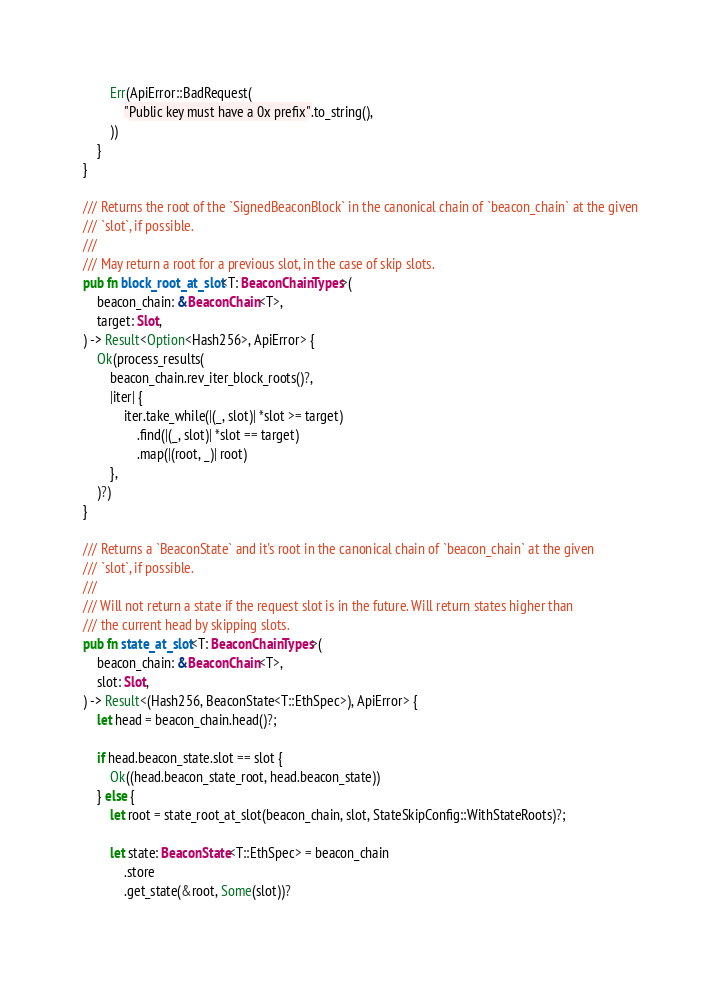<code> <loc_0><loc_0><loc_500><loc_500><_Rust_>        Err(ApiError::BadRequest(
            "Public key must have a 0x prefix".to_string(),
        ))
    }
}

/// Returns the root of the `SignedBeaconBlock` in the canonical chain of `beacon_chain` at the given
/// `slot`, if possible.
///
/// May return a root for a previous slot, in the case of skip slots.
pub fn block_root_at_slot<T: BeaconChainTypes>(
    beacon_chain: &BeaconChain<T>,
    target: Slot,
) -> Result<Option<Hash256>, ApiError> {
    Ok(process_results(
        beacon_chain.rev_iter_block_roots()?,
        |iter| {
            iter.take_while(|(_, slot)| *slot >= target)
                .find(|(_, slot)| *slot == target)
                .map(|(root, _)| root)
        },
    )?)
}

/// Returns a `BeaconState` and it's root in the canonical chain of `beacon_chain` at the given
/// `slot`, if possible.
///
/// Will not return a state if the request slot is in the future. Will return states higher than
/// the current head by skipping slots.
pub fn state_at_slot<T: BeaconChainTypes>(
    beacon_chain: &BeaconChain<T>,
    slot: Slot,
) -> Result<(Hash256, BeaconState<T::EthSpec>), ApiError> {
    let head = beacon_chain.head()?;

    if head.beacon_state.slot == slot {
        Ok((head.beacon_state_root, head.beacon_state))
    } else {
        let root = state_root_at_slot(beacon_chain, slot, StateSkipConfig::WithStateRoots)?;

        let state: BeaconState<T::EthSpec> = beacon_chain
            .store
            .get_state(&root, Some(slot))?</code> 